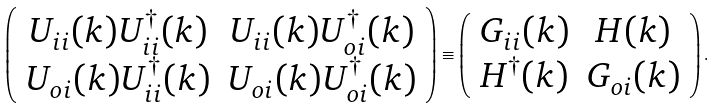Convert formula to latex. <formula><loc_0><loc_0><loc_500><loc_500>\left ( \begin{array} { c c } U _ { i i } ( k ) U _ { i i } ^ { \dagger } ( k ) & U _ { i i } ( k ) U _ { o i } ^ { \dagger } ( k ) \\ U _ { o i } ( k ) U _ { i i } ^ { \dagger } ( k ) & U _ { o i } ( k ) U _ { o i } ^ { \dagger } ( k ) \\ \end{array} \right ) \equiv \left ( \begin{array} { c c } G _ { i i } ( k ) & H ( k ) \\ H ^ { \dagger } ( k ) & G _ { o i } ( k ) \\ \end{array} \right ) .</formula> 